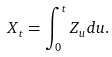Convert formula to latex. <formula><loc_0><loc_0><loc_500><loc_500>X _ { t } = \int _ { 0 } ^ { t } Z _ { u } d u .</formula> 